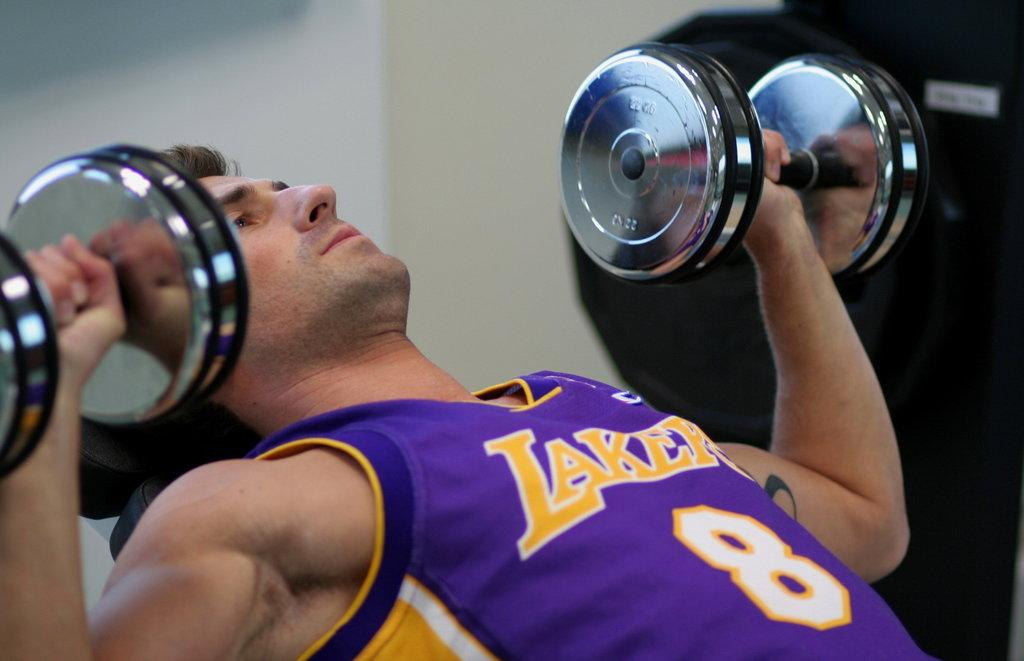Provide a one-sentence caption for the provided image. a man lifting weights while wearing a lakers jersey. 